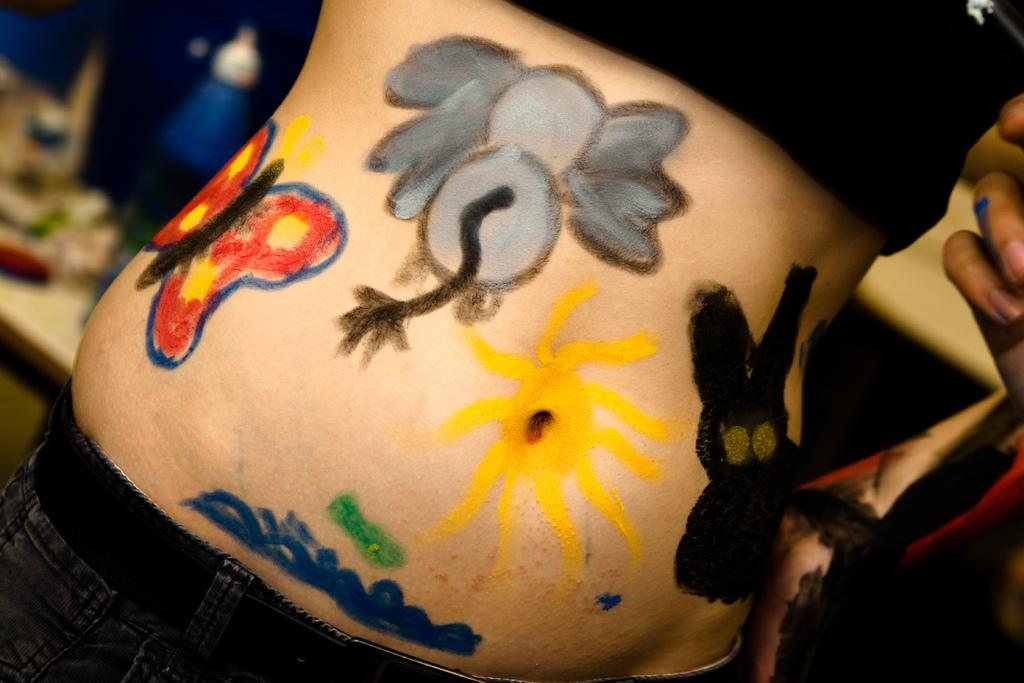What is unique about the person's stomach in the image? There is a painting on a person's stomach in the image. Can you describe the background of the image? The background of the image appears blurry. How many giants can be seen in the image? There are no giants present in the image. What is the thing that the person is holding in the image? The provided facts do not mention any object being held by the person in the image. 